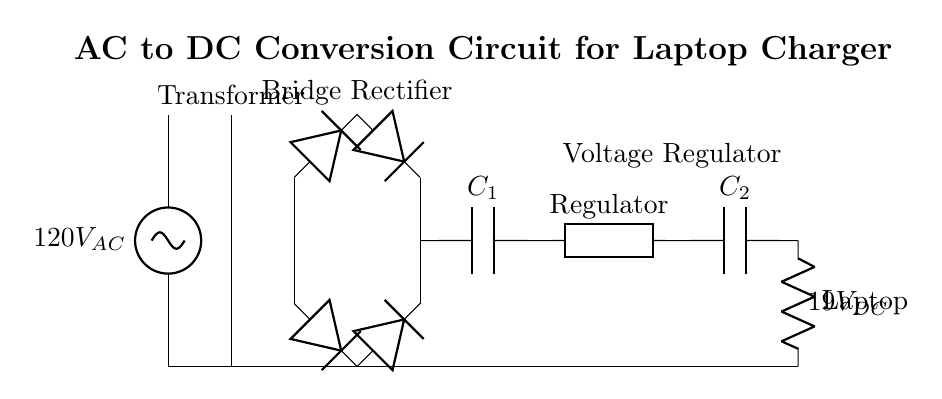What is the input voltage of the circuit? The input voltage is marked as 120V AC, which is specified at the AC source.
Answer: 120V AC What component converts AC to DC? The bridge rectifier is the component that converts AC voltage to DC voltage by allowing current to flow in one direction, effectively rectifying the alternating current.
Answer: Bridge Rectifier What is the purpose of the transformer in this circuit? The transformer steps down the incoming AC voltage from the power line, adjusting it to a lower level suitable for the charger output.
Answer: Step down voltage What is the output voltage of the circuit? The output voltage is indicated as 19V DC, which is the final voltage supplied to the laptop after rectification and regulation.
Answer: 19V DC What type of capacitor is used for smoothing? The capacitor labeled C1 is used for smoothing the output from the bridge rectifier, filtering out voltage fluctuations.
Answer: Smoothing Capacitor How many diodes are in the bridge rectifier? The bridge rectifier consists of four diodes that are arranged in a bridge configuration to effectively convert AC to DC.
Answer: Four diodes What is the function of the voltage regulator in the circuit? The voltage regulator stabilizes the output voltage at 19V DC, ensuring consistent power delivery to the load regardless of input voltage variations.
Answer: Stabilizes output voltage 